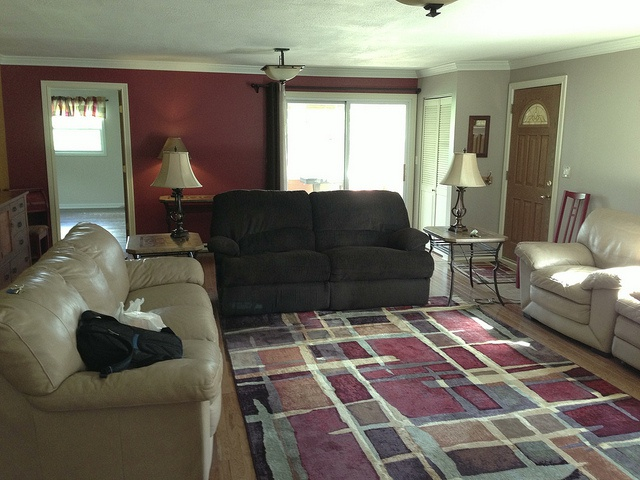Describe the objects in this image and their specific colors. I can see couch in gray, black, and darkgreen tones, couch in gray, black, and darkgray tones, chair in gray, darkgray, and ivory tones, backpack in gray, black, darkgreen, and darkblue tones, and couch in gray, ivory, and black tones in this image. 